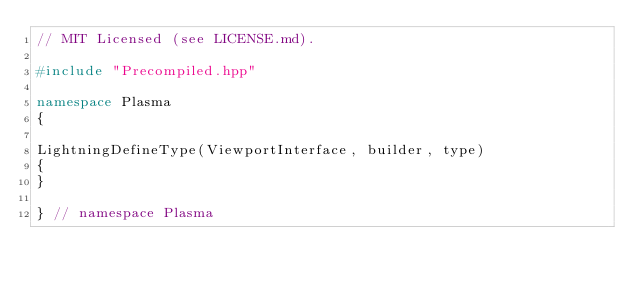Convert code to text. <code><loc_0><loc_0><loc_500><loc_500><_C++_>// MIT Licensed (see LICENSE.md).

#include "Precompiled.hpp"

namespace Plasma
{

LightningDefineType(ViewportInterface, builder, type)
{
}

} // namespace Plasma
</code> 